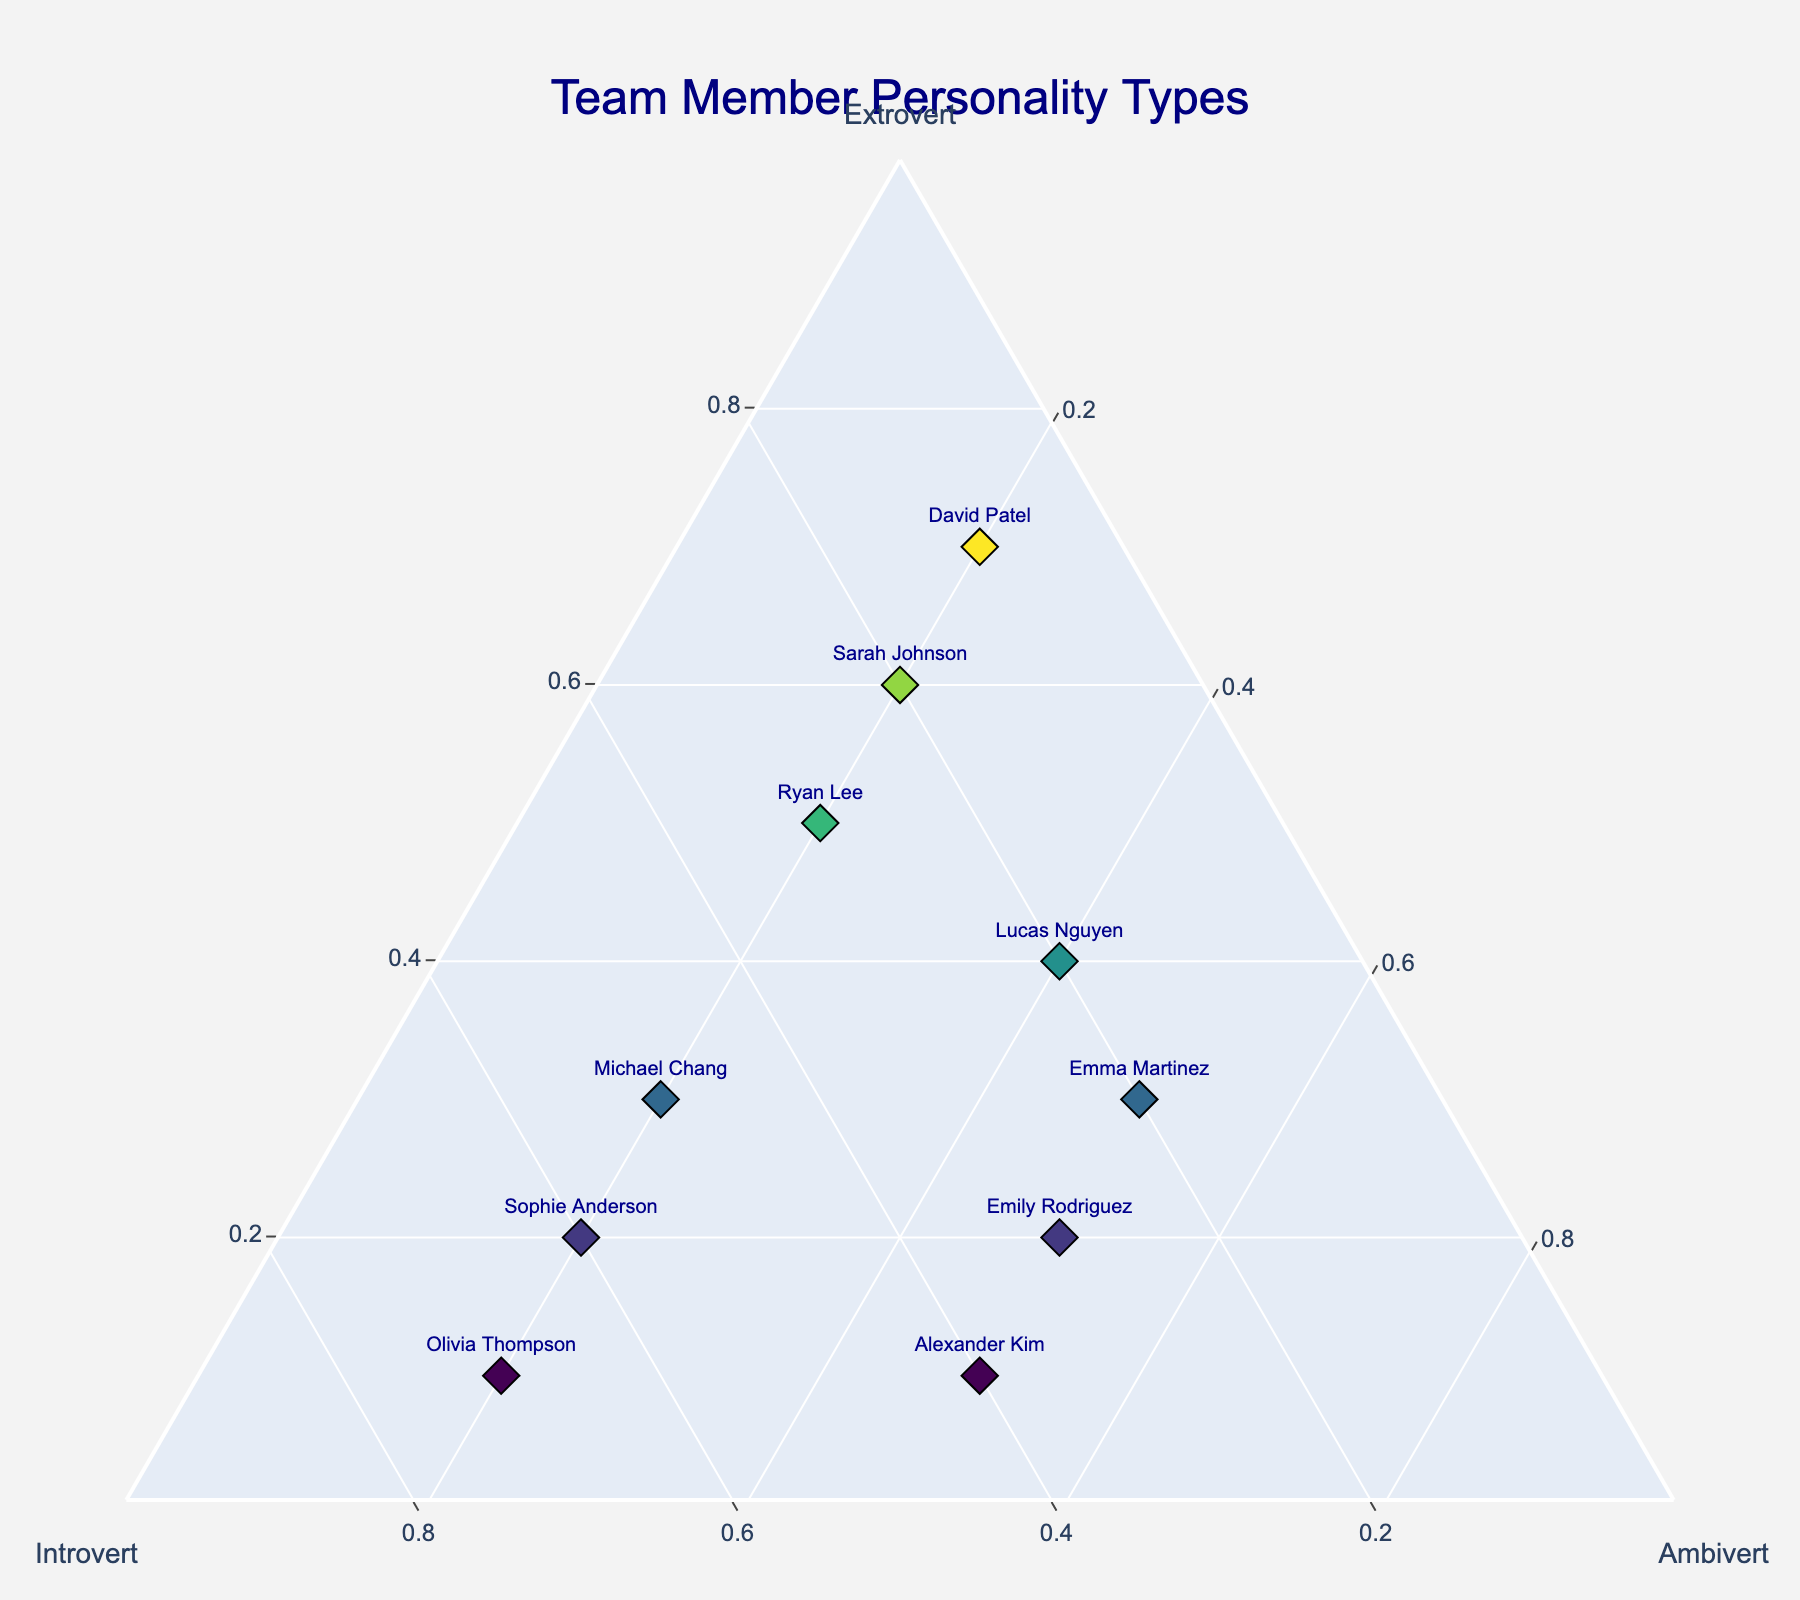How many team members lean more towards being extroverts than introverts? To determine how many team members lean more towards being extroverts than introverts, we need to compare the Extrovert proportions with the Introvert proportions for each team member. From the data, Sarah Johnson (0.6 > 0.2), David Patel (0.7 > 0.1), Lucas Nguyen (0.4 > 0.2), and Ryan Lee (0.5 > 0.3) lean more towards being extroverts.
Answer: 4 Which team member has the highest introvert tendency? Identify the team member with the highest value under the Introvert column. From the data, Olivia Thompson has the highest Introvert value of 0.7.
Answer: Olivia Thompson What is the average ambivert proportion of the team members? To find the average ambivert proportion, sum up all the values in the Ambivert column and divide by the number of team members. The values are (0.2 + 0.2 + 0.5 + 0.2 + 0.2 + 0.4 + 0.2 + 0.2 + 0.5 + 0.5), summing up to 3.2. There are 10 team members, so the average ambivert proportion is 3.2 / 10 = 0.32.
Answer: 0.32 Compare the personality compositions of Sarah Johnson and David Patel. Who is more extroverted, and who is more introverted? Look at the Extrovert and Introvert values for both Sarah Johnson and David Patel. Sarah Johnson is 0.6 Extrovert and 0.2 Introvert. David Patel is 0.7 Extrovert and 0.1 Introvert. David Patel is more extroverted (0.7 > 0.6) and less introverted (0.1 < 0.2).
Answer: David Patel is more extroverted; Sarah Johnson is more introverted Who has the closest balance among all three personality traits? To find the team member with the most balanced personality composition, identify who has the closest values across Extrovert, Introvert, and Ambivert. Lucas Nguyen's proportions are 0.4 Extrovert, 0.2 Introvert, and 0.4 Ambivert, which are closest to balance compared to others.
Answer: Lucas Nguyen Is there any team member who has identical proportions for Extrovert and Ambivert? Check for any team member whose Extrovert value is equal to their Ambivert value. From the data, no team member has identical proportions for Extrovert and Ambivert.
Answer: No Who is the most ambivert team member? Identify the team member with the highest value in the Ambivert column. Emily Rodriguez, Emma Martinez, and Alexander Kim all have the highest Ambivert value of 0.5.
Answer: Emily Rodriguez, Emma Martinez, Alexander Kim What's the sum of extrovert proportions of all team members? To find the sum of extrovert proportions, add up all the values in the Extrovert column. The values are (0.6 + 0.3 + 0.2 + 0.7 + 0.1 + 0.4 + 0.2 + 0.5 + 0.3 + 0.1), summing up to 3.4.
Answer: 3.4 Which team member is the least extroverted? Identify the team member with the lowest value in the Extrovert column. Olivia Thompson and Alexander Kim both have the lowest Extrovert value of 0.1.
Answer: Olivia Thompson, Alexander Kim 